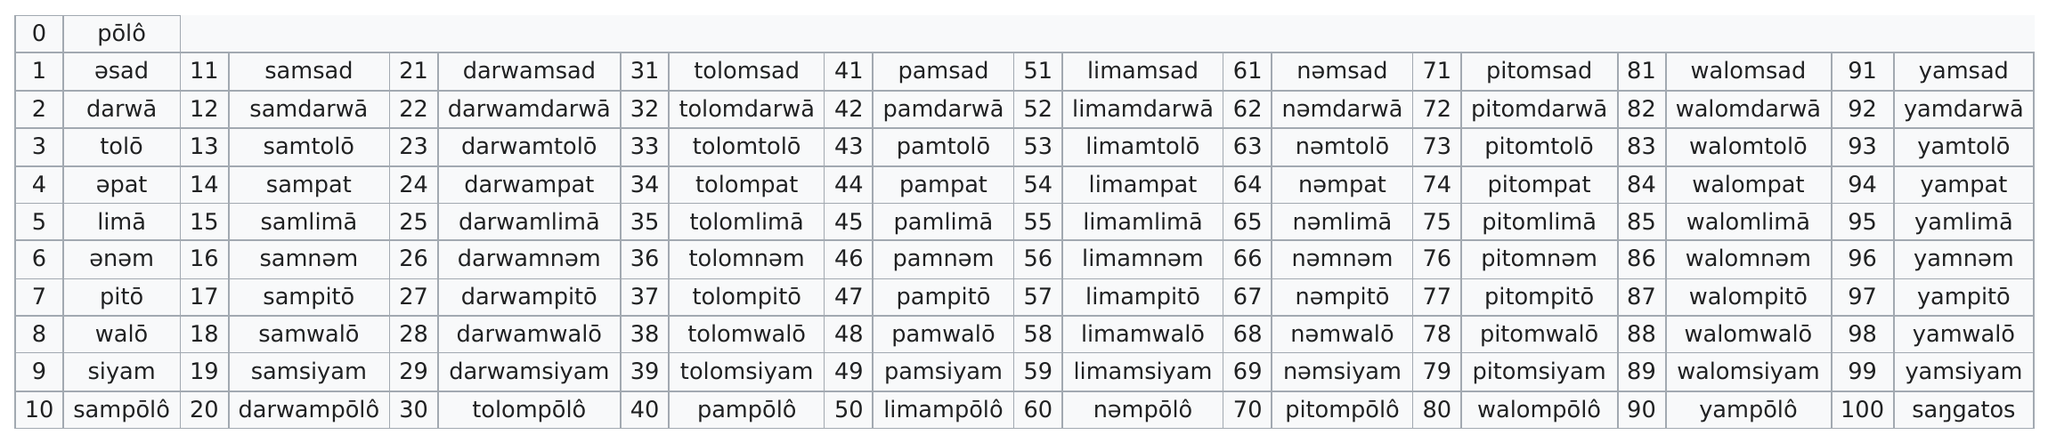Mention a couple of crucial points in this snapshot. In the Bikol language, the last single digit integer is siyam. 